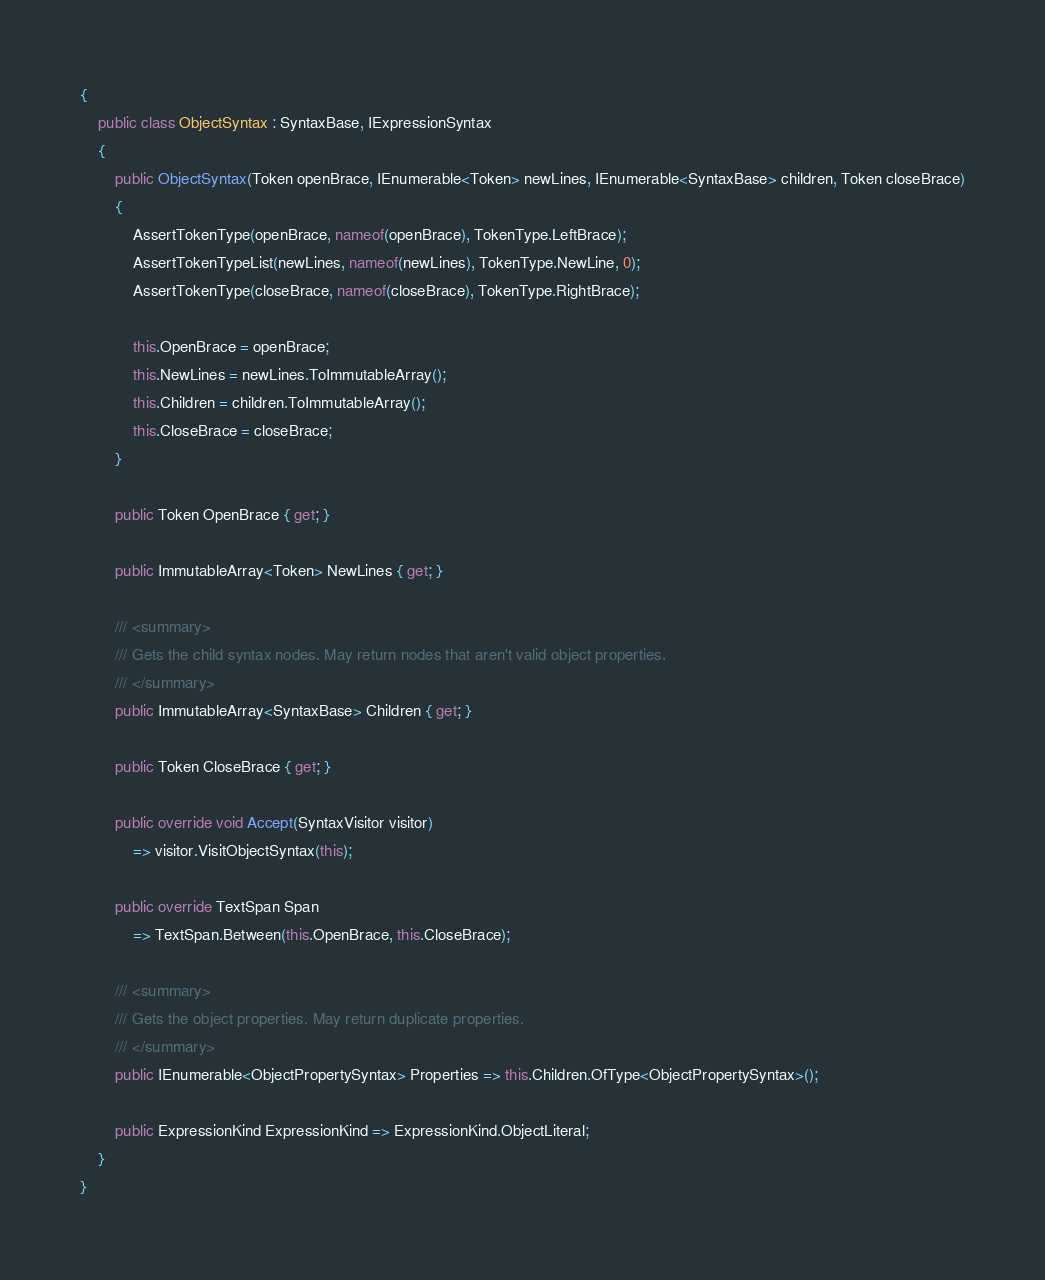Convert code to text. <code><loc_0><loc_0><loc_500><loc_500><_C#_>{
    public class ObjectSyntax : SyntaxBase, IExpressionSyntax
    {
        public ObjectSyntax(Token openBrace, IEnumerable<Token> newLines, IEnumerable<SyntaxBase> children, Token closeBrace)
        {
            AssertTokenType(openBrace, nameof(openBrace), TokenType.LeftBrace);
            AssertTokenTypeList(newLines, nameof(newLines), TokenType.NewLine, 0);
            AssertTokenType(closeBrace, nameof(closeBrace), TokenType.RightBrace);

            this.OpenBrace = openBrace;
            this.NewLines = newLines.ToImmutableArray();
            this.Children = children.ToImmutableArray();
            this.CloseBrace = closeBrace;
        }

        public Token OpenBrace { get; }

        public ImmutableArray<Token> NewLines { get; }

        /// <summary>
        /// Gets the child syntax nodes. May return nodes that aren't valid object properties.
        /// </summary>
        public ImmutableArray<SyntaxBase> Children { get; }

        public Token CloseBrace { get; }

        public override void Accept(SyntaxVisitor visitor)
            => visitor.VisitObjectSyntax(this);

        public override TextSpan Span
            => TextSpan.Between(this.OpenBrace, this.CloseBrace);

        /// <summary>
        /// Gets the object properties. May return duplicate properties.
        /// </summary>
        public IEnumerable<ObjectPropertySyntax> Properties => this.Children.OfType<ObjectPropertySyntax>();

        public ExpressionKind ExpressionKind => ExpressionKind.ObjectLiteral;
    }
}
</code> 